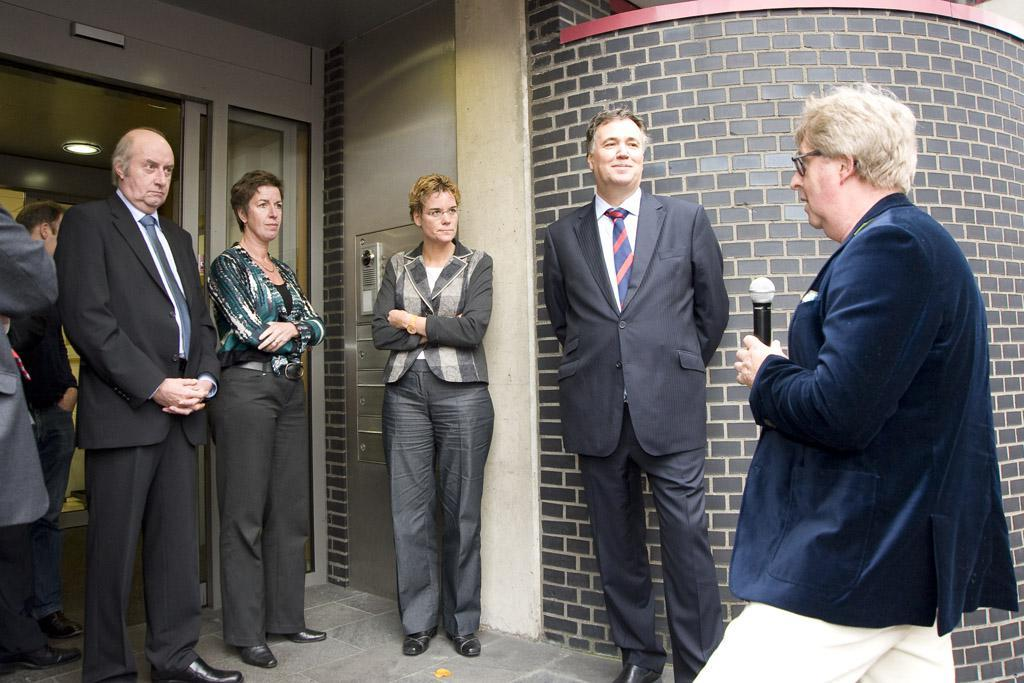What is happening in front of the door in the image? There are persons visible in front of a door. Can you describe the person on the right side of the image? The person on the right side of the image is holding a microphone. What is attached to the roof on the left side of the image? There is a light visible attached to the roof on the left side. How many pies are being served to the pets in the image? There are no pies or pets present in the image. What is the thumb doing in the image? There is no thumb visible in the image. 